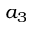<formula> <loc_0><loc_0><loc_500><loc_500>a _ { 3 }</formula> 